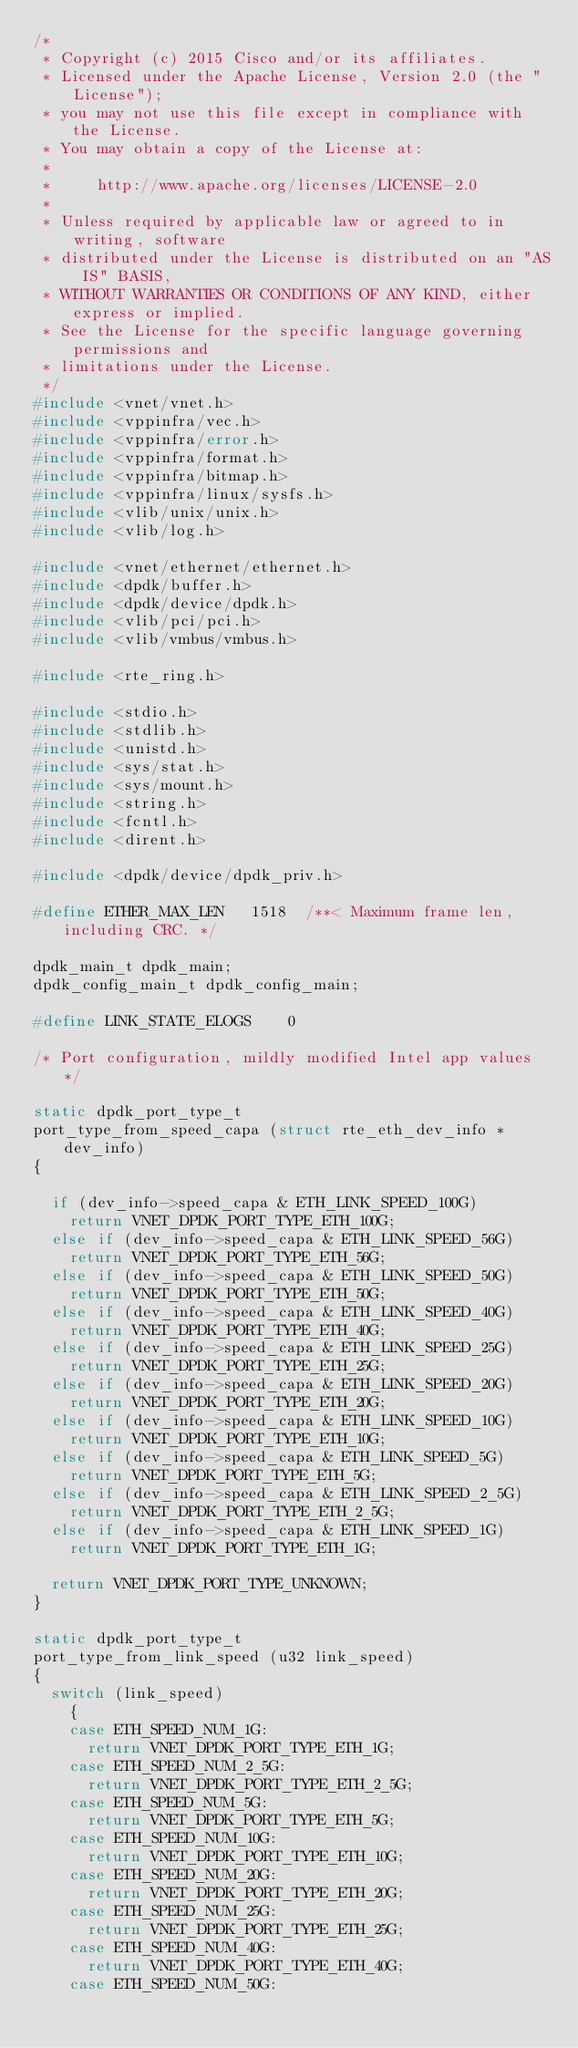<code> <loc_0><loc_0><loc_500><loc_500><_C_>/*
 * Copyright (c) 2015 Cisco and/or its affiliates.
 * Licensed under the Apache License, Version 2.0 (the "License");
 * you may not use this file except in compliance with the License.
 * You may obtain a copy of the License at:
 *
 *     http://www.apache.org/licenses/LICENSE-2.0
 *
 * Unless required by applicable law or agreed to in writing, software
 * distributed under the License is distributed on an "AS IS" BASIS,
 * WITHOUT WARRANTIES OR CONDITIONS OF ANY KIND, either express or implied.
 * See the License for the specific language governing permissions and
 * limitations under the License.
 */
#include <vnet/vnet.h>
#include <vppinfra/vec.h>
#include <vppinfra/error.h>
#include <vppinfra/format.h>
#include <vppinfra/bitmap.h>
#include <vppinfra/linux/sysfs.h>
#include <vlib/unix/unix.h>
#include <vlib/log.h>

#include <vnet/ethernet/ethernet.h>
#include <dpdk/buffer.h>
#include <dpdk/device/dpdk.h>
#include <vlib/pci/pci.h>
#include <vlib/vmbus/vmbus.h>

#include <rte_ring.h>

#include <stdio.h>
#include <stdlib.h>
#include <unistd.h>
#include <sys/stat.h>
#include <sys/mount.h>
#include <string.h>
#include <fcntl.h>
#include <dirent.h>

#include <dpdk/device/dpdk_priv.h>

#define ETHER_MAX_LEN   1518  /**< Maximum frame len, including CRC. */

dpdk_main_t dpdk_main;
dpdk_config_main_t dpdk_config_main;

#define LINK_STATE_ELOGS	0

/* Port configuration, mildly modified Intel app values */

static dpdk_port_type_t
port_type_from_speed_capa (struct rte_eth_dev_info *dev_info)
{

  if (dev_info->speed_capa & ETH_LINK_SPEED_100G)
    return VNET_DPDK_PORT_TYPE_ETH_100G;
  else if (dev_info->speed_capa & ETH_LINK_SPEED_56G)
    return VNET_DPDK_PORT_TYPE_ETH_56G;
  else if (dev_info->speed_capa & ETH_LINK_SPEED_50G)
    return VNET_DPDK_PORT_TYPE_ETH_50G;
  else if (dev_info->speed_capa & ETH_LINK_SPEED_40G)
    return VNET_DPDK_PORT_TYPE_ETH_40G;
  else if (dev_info->speed_capa & ETH_LINK_SPEED_25G)
    return VNET_DPDK_PORT_TYPE_ETH_25G;
  else if (dev_info->speed_capa & ETH_LINK_SPEED_20G)
    return VNET_DPDK_PORT_TYPE_ETH_20G;
  else if (dev_info->speed_capa & ETH_LINK_SPEED_10G)
    return VNET_DPDK_PORT_TYPE_ETH_10G;
  else if (dev_info->speed_capa & ETH_LINK_SPEED_5G)
    return VNET_DPDK_PORT_TYPE_ETH_5G;
  else if (dev_info->speed_capa & ETH_LINK_SPEED_2_5G)
    return VNET_DPDK_PORT_TYPE_ETH_2_5G;
  else if (dev_info->speed_capa & ETH_LINK_SPEED_1G)
    return VNET_DPDK_PORT_TYPE_ETH_1G;

  return VNET_DPDK_PORT_TYPE_UNKNOWN;
}

static dpdk_port_type_t
port_type_from_link_speed (u32 link_speed)
{
  switch (link_speed)
    {
    case ETH_SPEED_NUM_1G:
      return VNET_DPDK_PORT_TYPE_ETH_1G;
    case ETH_SPEED_NUM_2_5G:
      return VNET_DPDK_PORT_TYPE_ETH_2_5G;
    case ETH_SPEED_NUM_5G:
      return VNET_DPDK_PORT_TYPE_ETH_5G;
    case ETH_SPEED_NUM_10G:
      return VNET_DPDK_PORT_TYPE_ETH_10G;
    case ETH_SPEED_NUM_20G:
      return VNET_DPDK_PORT_TYPE_ETH_20G;
    case ETH_SPEED_NUM_25G:
      return VNET_DPDK_PORT_TYPE_ETH_25G;
    case ETH_SPEED_NUM_40G:
      return VNET_DPDK_PORT_TYPE_ETH_40G;
    case ETH_SPEED_NUM_50G:</code> 